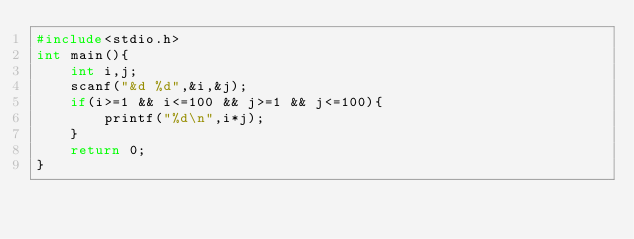<code> <loc_0><loc_0><loc_500><loc_500><_C_>#include<stdio.h>
int main(){
    int i,j;
    scanf("&d %d",&i,&j);
    if(i>=1 && i<=100 && j>=1 && j<=100){
        printf("%d\n",i*j);
    }
    return 0;
}
</code> 